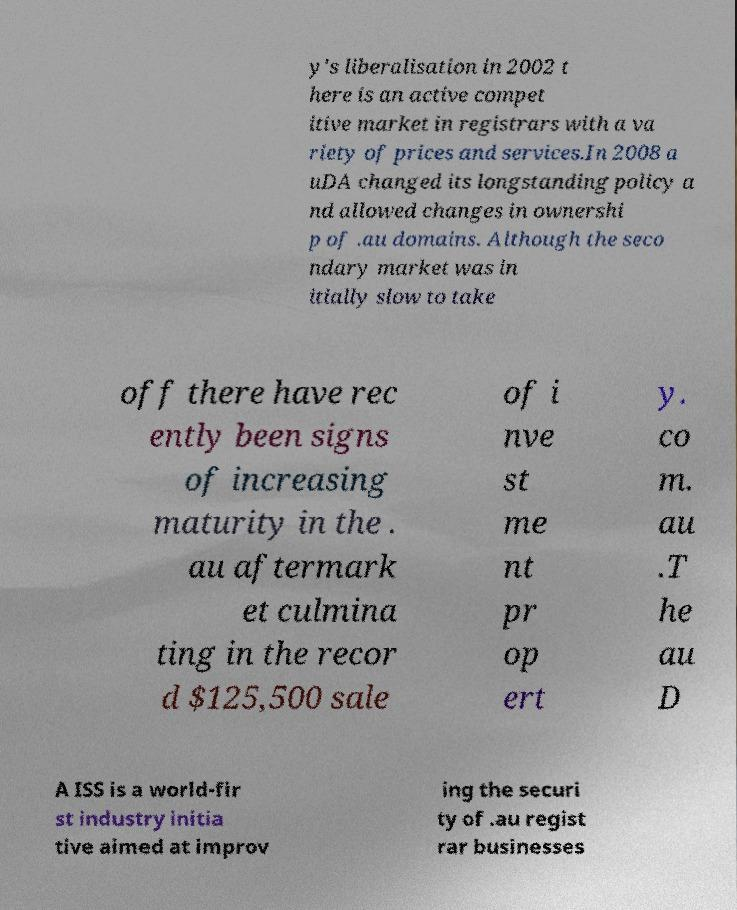There's text embedded in this image that I need extracted. Can you transcribe it verbatim? y's liberalisation in 2002 t here is an active compet itive market in registrars with a va riety of prices and services.In 2008 a uDA changed its longstanding policy a nd allowed changes in ownershi p of .au domains. Although the seco ndary market was in itially slow to take off there have rec ently been signs of increasing maturity in the . au aftermark et culmina ting in the recor d $125,500 sale of i nve st me nt pr op ert y. co m. au .T he au D A ISS is a world-fir st industry initia tive aimed at improv ing the securi ty of .au regist rar businesses 